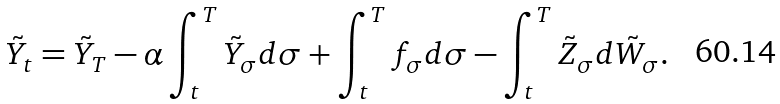<formula> <loc_0><loc_0><loc_500><loc_500>\tilde { Y } _ { t } = \tilde { Y } _ { T } - \alpha \int _ { t } ^ { T } \tilde { Y } _ { \sigma } d \sigma + \int _ { t } ^ { T } f _ { \sigma } d \sigma - \int _ { t } ^ { T } \tilde { Z } _ { \sigma } d \tilde { W } _ { \sigma } .</formula> 